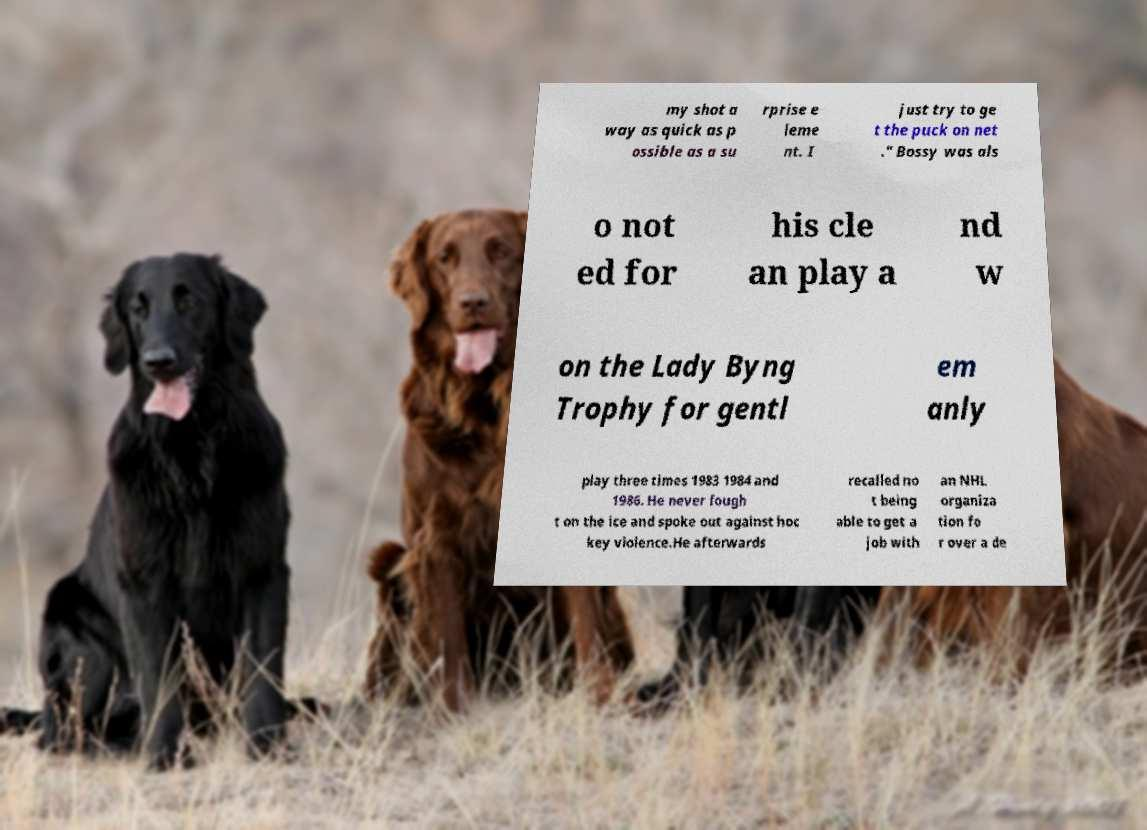For documentation purposes, I need the text within this image transcribed. Could you provide that? my shot a way as quick as p ossible as a su rprise e leme nt. I just try to ge t the puck on net ." Bossy was als o not ed for his cle an play a nd w on the Lady Byng Trophy for gentl em anly play three times 1983 1984 and 1986. He never fough t on the ice and spoke out against hoc key violence.He afterwards recalled no t being able to get a job with an NHL organiza tion fo r over a de 